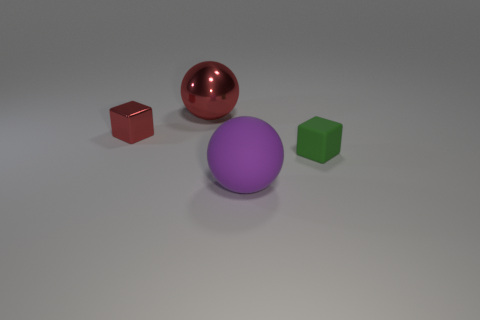How many purple spheres have the same material as the green cube?
Your answer should be very brief. 1. What number of matte spheres are to the left of the large sphere in front of the tiny green rubber object?
Your answer should be very brief. 0. There is a small green cube; are there any blocks to the left of it?
Make the answer very short. Yes. There is a tiny object on the right side of the large purple sphere; is it the same shape as the big shiny object?
Your answer should be very brief. No. What is the material of the ball that is the same color as the small metal block?
Provide a succinct answer. Metal. How many small blocks have the same color as the tiny shiny object?
Offer a terse response. 0. What is the shape of the big object that is behind the ball that is right of the large red thing?
Ensure brevity in your answer.  Sphere. Are there any large gray metal things of the same shape as the small red shiny thing?
Offer a terse response. No. There is a small rubber cube; does it have the same color as the sphere that is in front of the tiny red thing?
Offer a very short reply. No. There is a metallic thing that is the same color as the large shiny sphere; what size is it?
Keep it short and to the point. Small. 